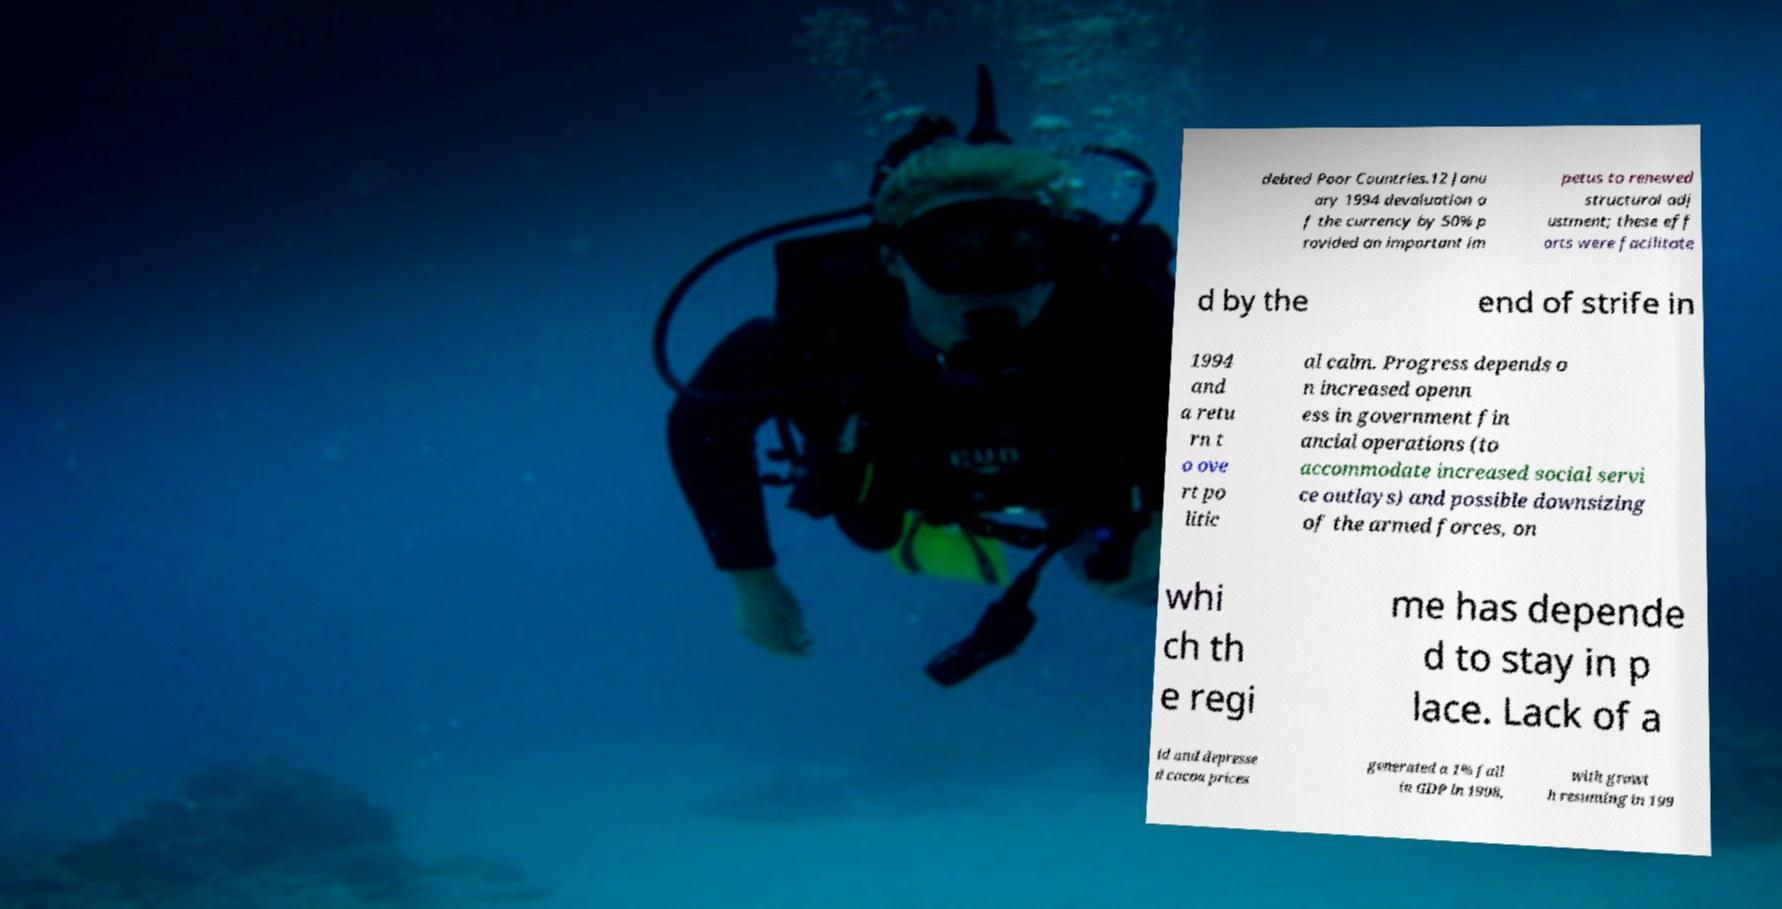Could you assist in decoding the text presented in this image and type it out clearly? debted Poor Countries.12 Janu ary 1994 devaluation o f the currency by 50% p rovided an important im petus to renewed structural adj ustment; these eff orts were facilitate d by the end of strife in 1994 and a retu rn t o ove rt po litic al calm. Progress depends o n increased openn ess in government fin ancial operations (to accommodate increased social servi ce outlays) and possible downsizing of the armed forces, on whi ch th e regi me has depende d to stay in p lace. Lack of a id and depresse d cocoa prices generated a 1% fall in GDP in 1998, with growt h resuming in 199 